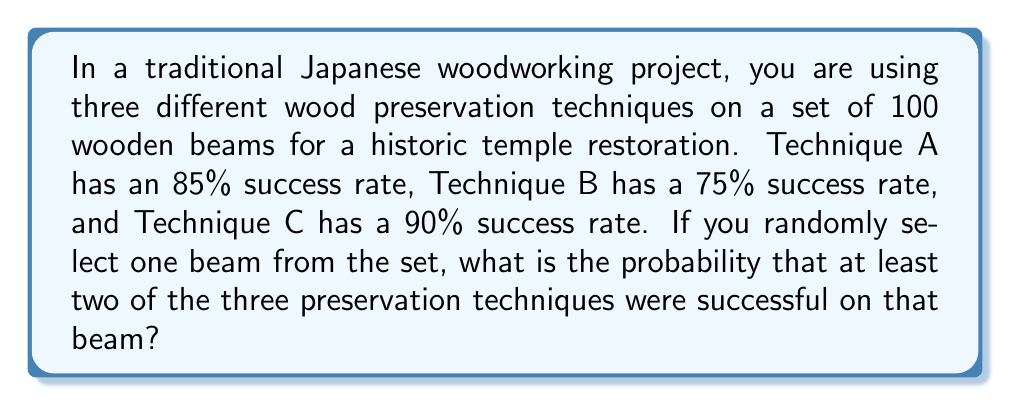What is the answer to this math problem? Let's approach this step-by-step using probability theory:

1) First, let's define our events:
   A: Technique A is successful (P(A) = 0.85)
   B: Technique B is successful (P(B) = 0.75)
   C: Technique C is successful (P(C) = 0.90)

2) We want the probability of at least two techniques being successful. It's easier to calculate the complement of this: the probability of 0 or 1 technique being successful, and then subtract from 1.

3) Probability of 0 successful techniques:
   $P(\text{none}) = (1-0.85)(1-0.75)(1-0.90) = 0.15 \times 0.25 \times 0.10 = 0.00375$

4) Probability of exactly 1 successful technique:
   $P(\text{only A}) = 0.85 \times 0.25 \times 0.10 = 0.02125$
   $P(\text{only B}) = 0.15 \times 0.75 \times 0.10 = 0.01125$
   $P(\text{only C}) = 0.15 \times 0.25 \times 0.90 = 0.03375$
   
   $P(\text{exactly one}) = 0.02125 + 0.01125 + 0.03375 = 0.06625$

5) Probability of 0 or 1 successful technique:
   $P(0 \text{ or } 1) = 0.00375 + 0.06625 = 0.07$

6) Therefore, the probability of at least 2 successful techniques:
   $P(\text{at least 2}) = 1 - P(0 \text{ or } 1) = 1 - 0.07 = 0.93$

Thus, the probability that at least two of the three preservation techniques were successful on a randomly selected beam is 0.93 or 93%.
Answer: 0.93 or 93% 